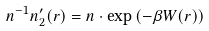Convert formula to latex. <formula><loc_0><loc_0><loc_500><loc_500>n ^ { - 1 } n ^ { \prime } _ { 2 } ( r ) = n \cdot \exp \left ( - \beta W ( r ) \right )</formula> 